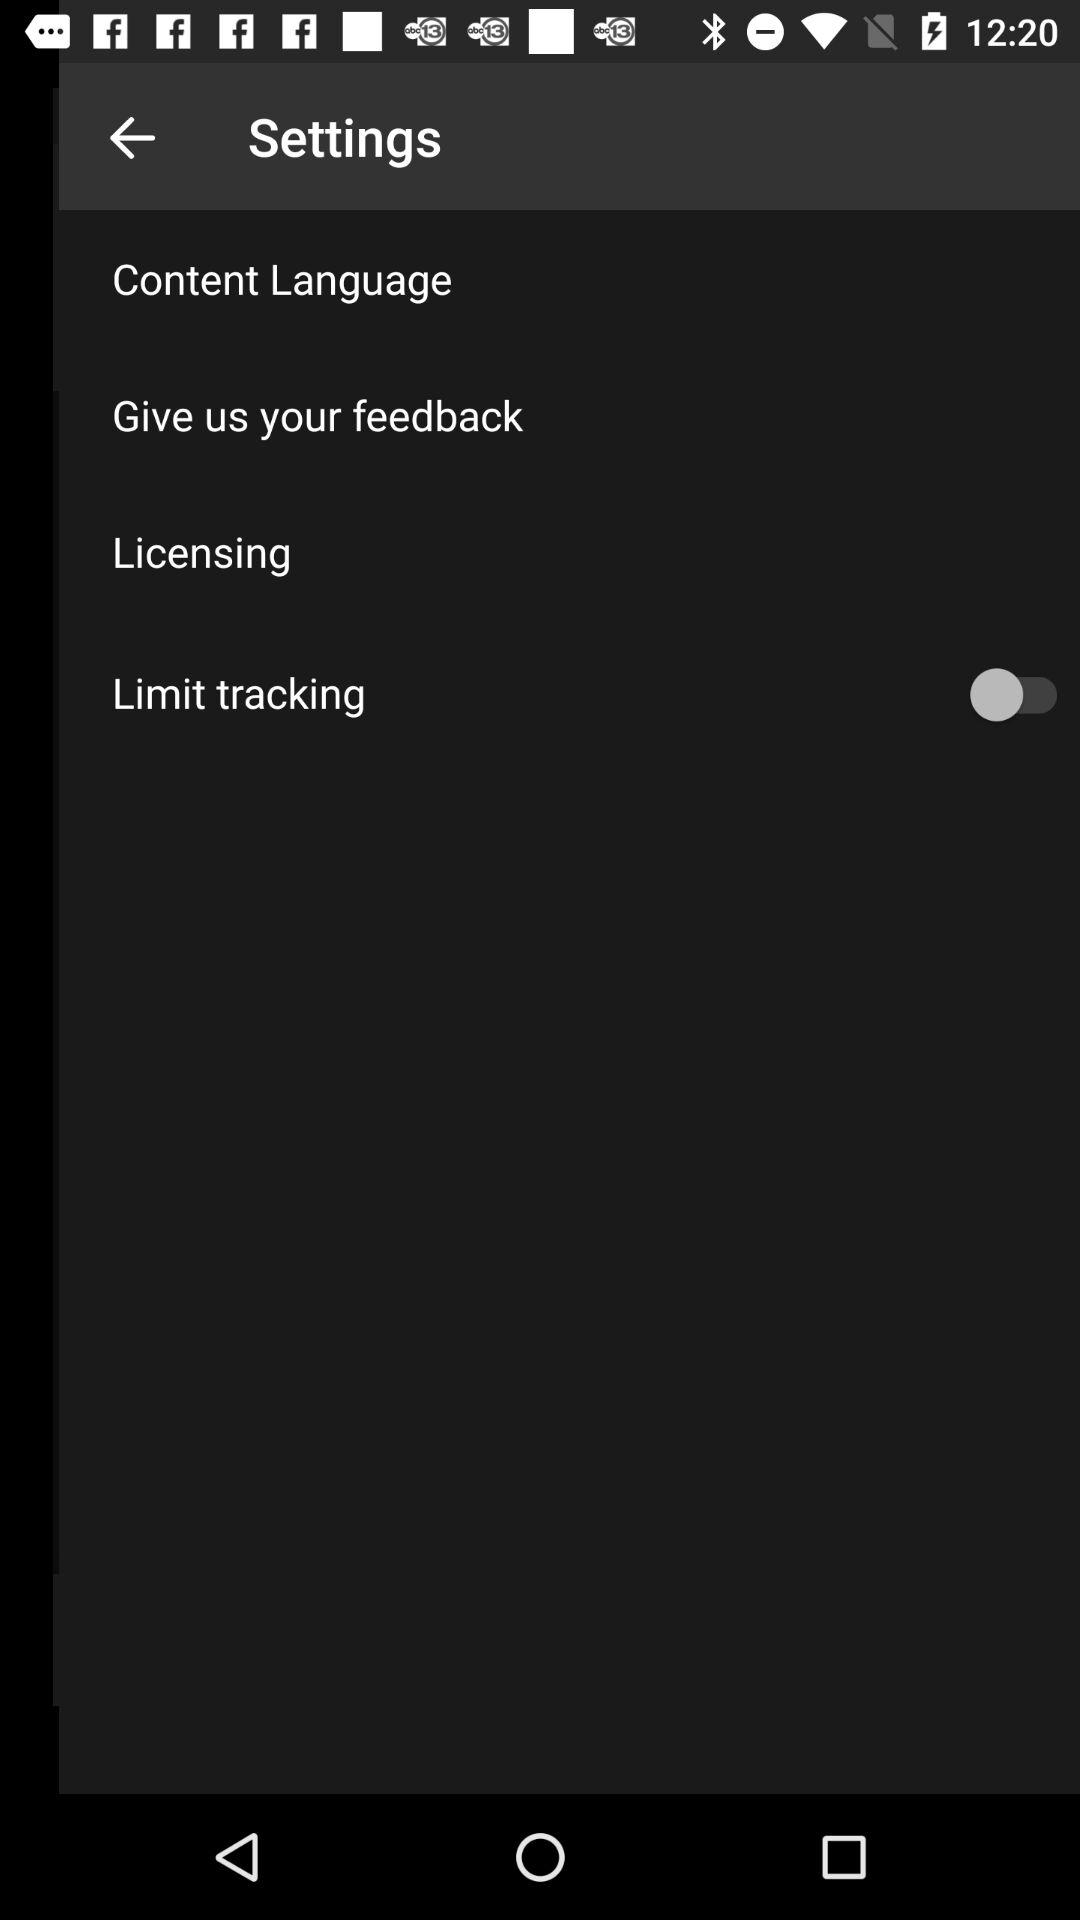What is the status of "Licensing"?
When the provided information is insufficient, respond with <no answer>. <no answer> 